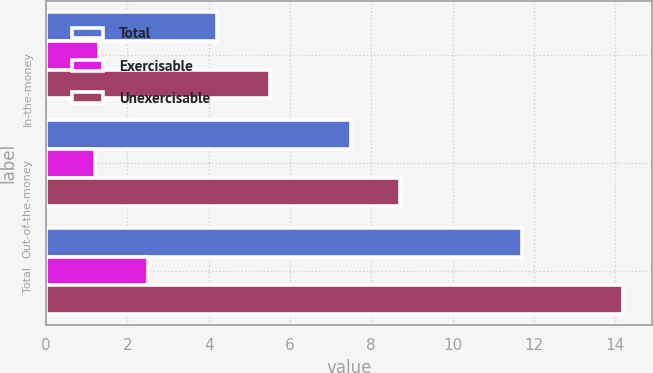Convert chart. <chart><loc_0><loc_0><loc_500><loc_500><stacked_bar_chart><ecel><fcel>In-the-money<fcel>Out-of-the-money<fcel>Total<nl><fcel>Total<fcel>4.2<fcel>7.5<fcel>11.7<nl><fcel>Exercisable<fcel>1.3<fcel>1.2<fcel>2.5<nl><fcel>Unexercisable<fcel>5.5<fcel>8.7<fcel>14.2<nl></chart> 